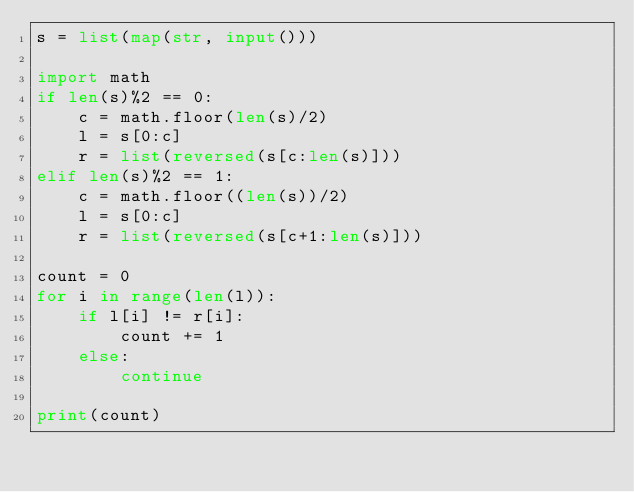<code> <loc_0><loc_0><loc_500><loc_500><_Python_>s = list(map(str, input()))

import math
if len(s)%2 == 0:
    c = math.floor(len(s)/2)
    l = s[0:c]
    r = list(reversed(s[c:len(s)]))
elif len(s)%2 == 1:
    c = math.floor((len(s))/2)
    l = s[0:c]
    r = list(reversed(s[c+1:len(s)]))
    
count = 0
for i in range(len(l)):
    if l[i] != r[i]:
        count += 1
    else:
        continue
        
print(count)</code> 